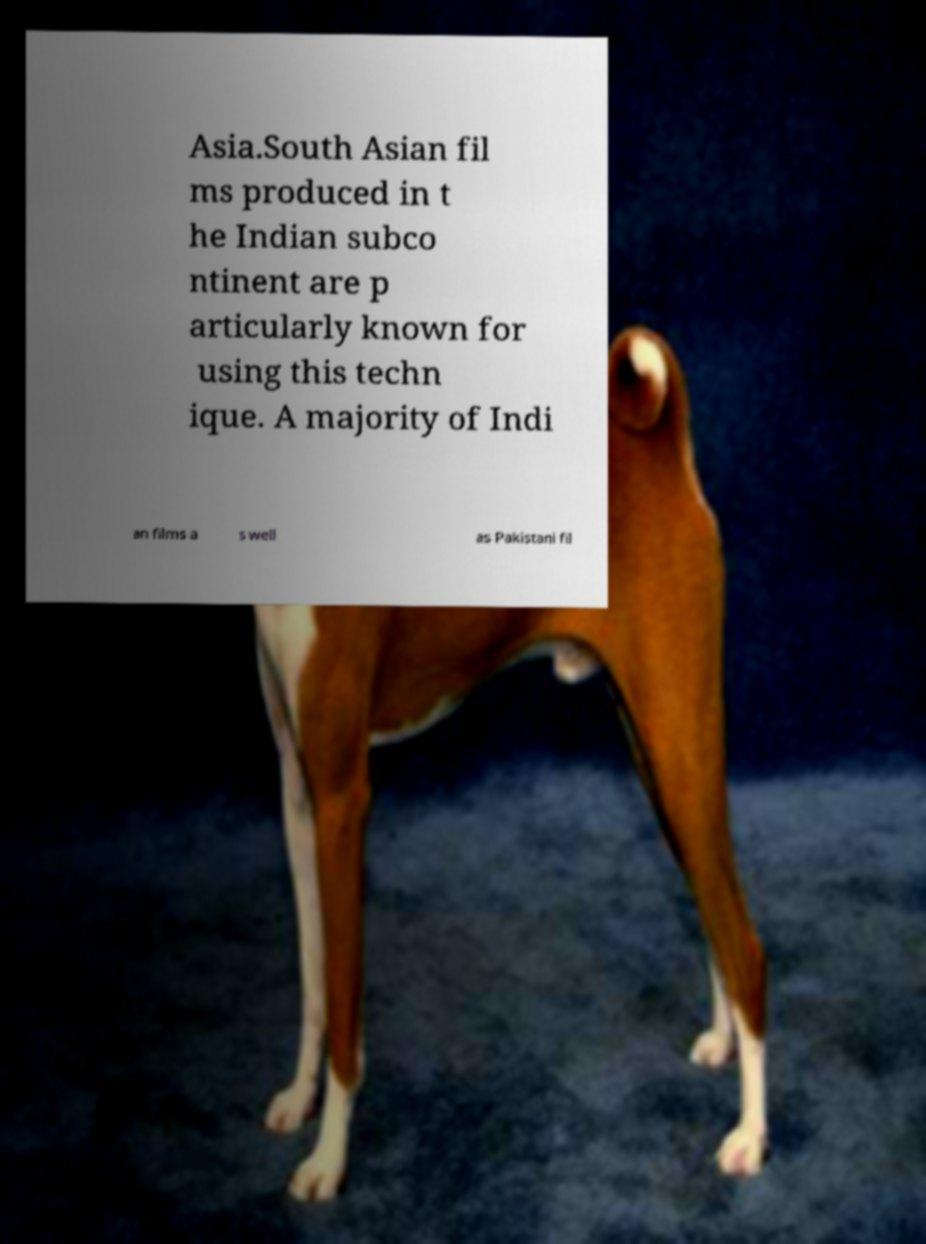Could you extract and type out the text from this image? Asia.South Asian fil ms produced in t he Indian subco ntinent are p articularly known for using this techn ique. A majority of Indi an films a s well as Pakistani fil 